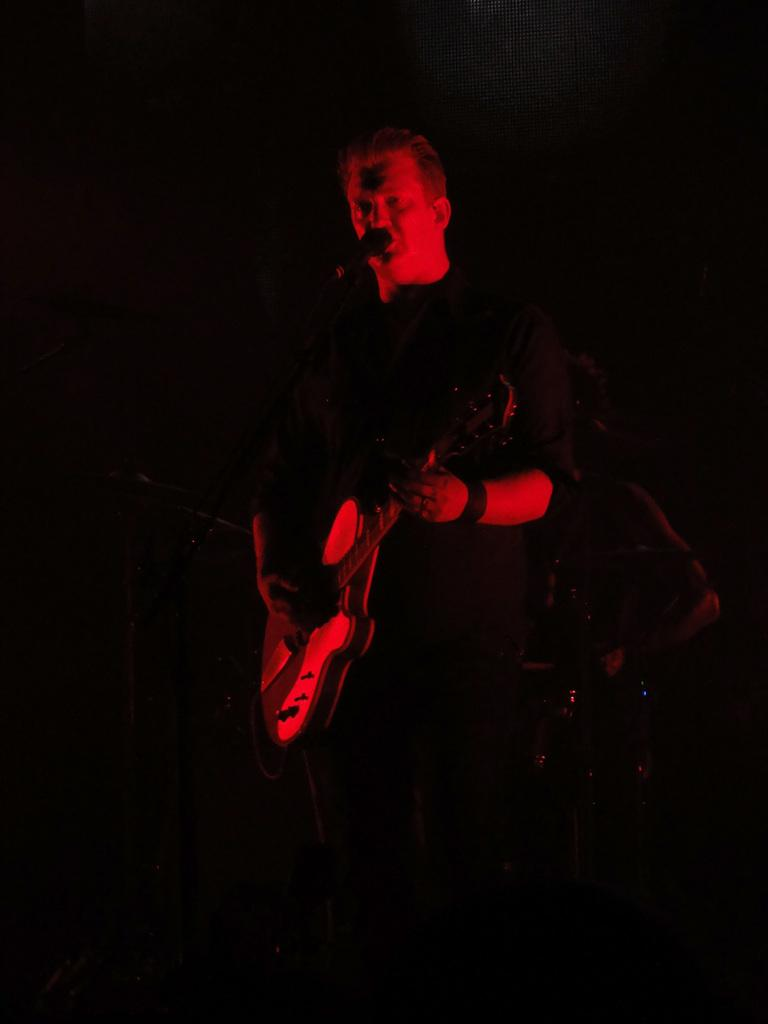Who or what is present in the image? There are people in the image. What are the people doing in the image? The people are standing and holding guitars. Is there any equipment related to music in the image? Yes, there is a microphone in the image. What type of furniture can be seen in the image? There is no furniture present in the image. Is there a scarecrow playing the guitar in the image? No, there are no scarecrows in the image; it features people holding guitars. Can you tell me how many dogs are visible in the image? There are no dogs present in the image. 